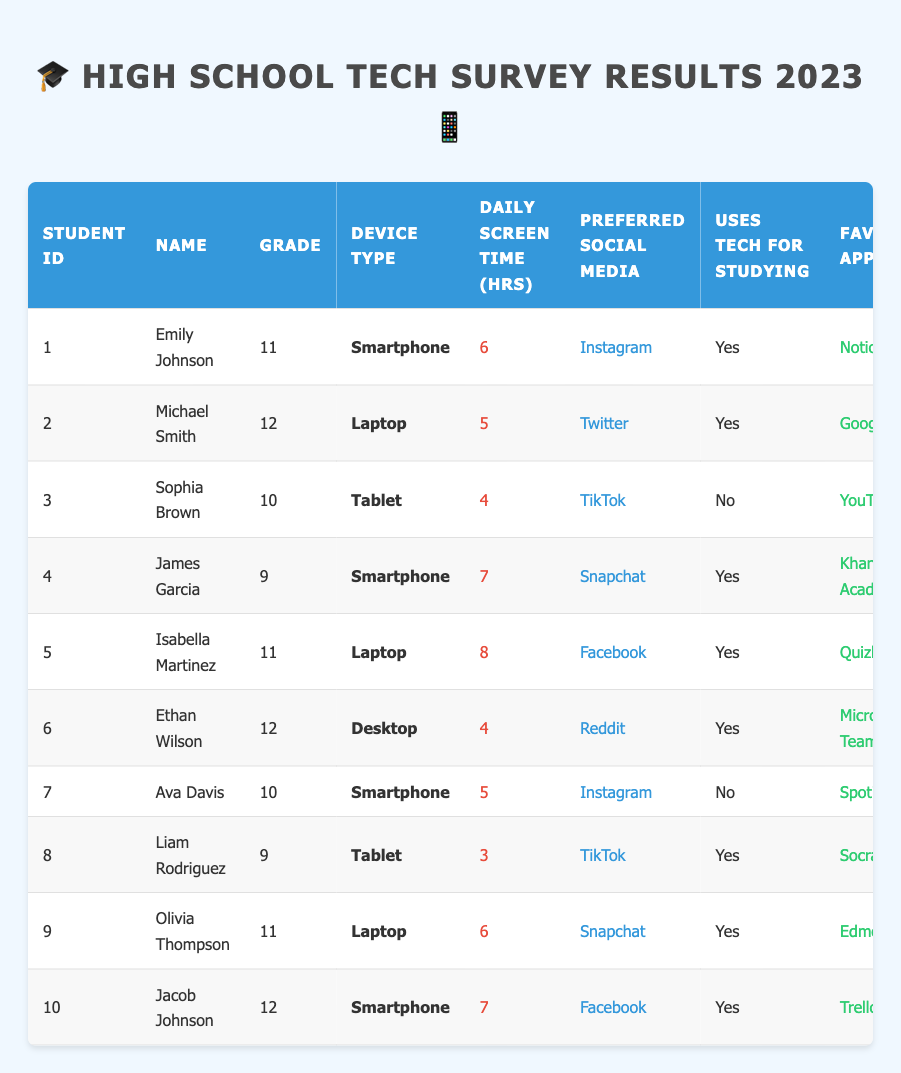What is the daily screen time of Emily Johnson? The table shows that Emily Johnson has a daily screen time of 6 hours listed under the "Daily Screen Time (hrs)" column.
Answer: 6 hours Which student uses a Tablet as their primary device? In the table, there are two students who use a Tablet: Sophia Brown and Liam Rodriguez.
Answer: Sophia Brown and Liam Rodriguez How many students use technology for studying? The table indicates that 6 students answer "Yes" to using technology for studying. Counting the "Yes" responses in the "Uses Tech for Studying" column gives us this number.
Answer: 6 What is the favorite app of Isabella Martinez? Looking at the table, Isabella Martinez's favorite app is mentioned as "Quizlet" in the "Favorite App" column.
Answer: Quizlet What is the average daily screen time of students in grade 11? The students in grade 11 are Emily Johnson (6), Isabella Martinez (8), and Olivia Thompson (6). Adding these gives 20 hours, and dividing by 3 students gives an average of 20/3 = 6.67.
Answer: 6.67 hours What is the total number of online classes attended by all the students? The online classes attended by each student in the table are summed up: 3 + 4 + 2 + 5 + 3 + 6 + 2 + 4 + 3 + 5 = 43.
Answer: 43 Do any students prefer TikTok as their social media? Referring to the table, two students, Sophia Brown and Liam Rodriguez, have TikTok listed as their preferred social media, indicating a "Yes" response to this question.
Answer: Yes Which student has the highest daily screen time? The table shows Isabella Martinez with 8 hours as the highest daily screen time among all entries, after checking the values in the "Daily Screen Time (hrs)" column.
Answer: Isabella Martinez How many students attend more than 4 online classes? From the table, the students who attended more than 4 online classes are Ethan Wilson (6) and James Garcia (5). There are 2 students that meet this criterion.
Answer: 2 What device type is used by the student who has the most preferred social media interactions? Checking the "Preferred Social Media" column shows that Instagram and Snapchat are popular among students, but the question is specifically about identifying the student with the highest daily screen time, which is Isabella Martinez using a Laptop.
Answer: Laptop 